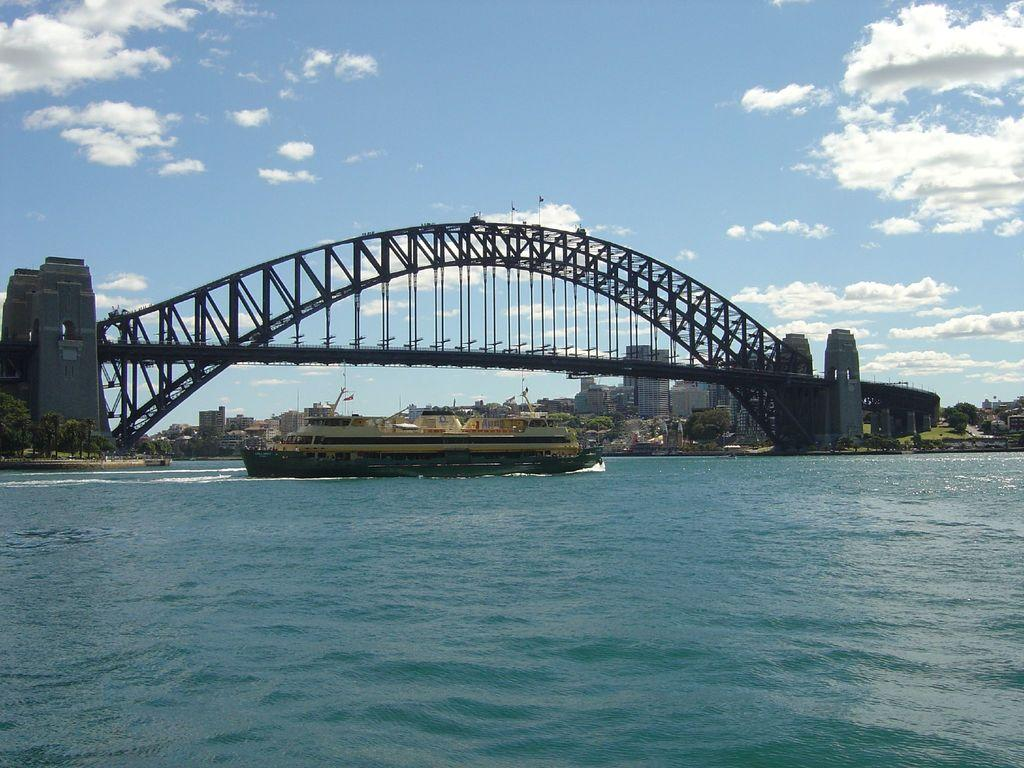What structure is located in the middle of the image? There is a bridge in the middle of the image. What is at the bottom of the image? There is a boat at the bottom of the image. What is the primary substance visible in the image? There is water visible in the image. What can be seen in the background of the image? There are buildings, trees, and the sky visible in the background of the image. What is the condition of the sky in the image? Clouds are present in the sky. What type of income can be seen in the image? There is no reference to income in the image; it features a bridge, a boat, water, buildings, trees, and a sky with clouds. How many balls are visible in the image? There are no balls present in the image. 